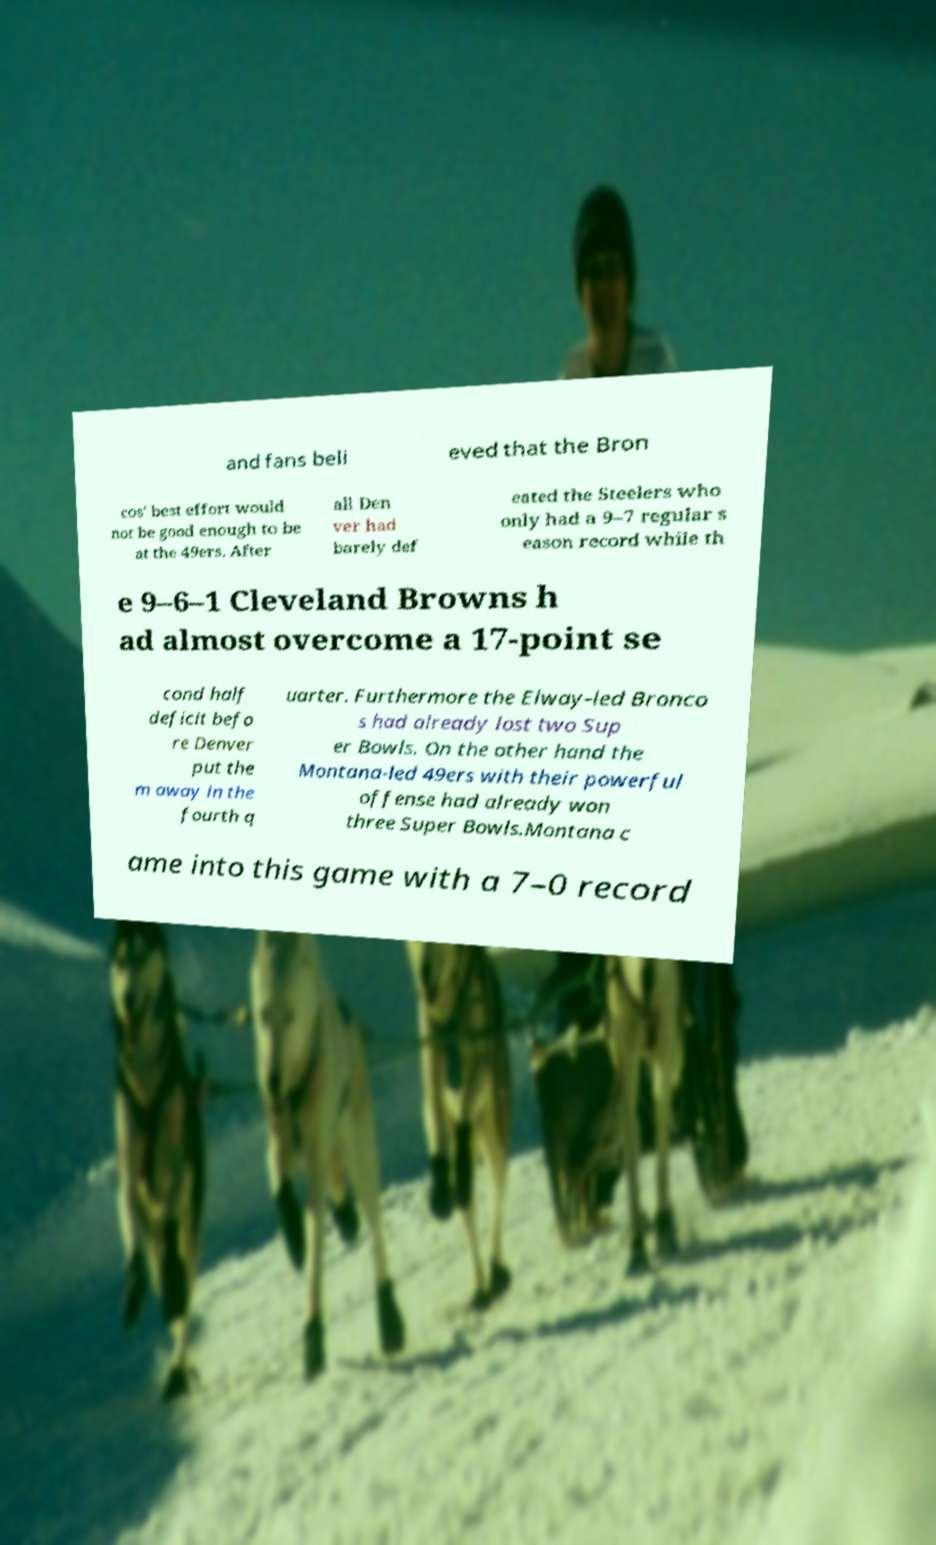Could you assist in decoding the text presented in this image and type it out clearly? and fans beli eved that the Bron cos' best effort would not be good enough to be at the 49ers. After all Den ver had barely def eated the Steelers who only had a 9–7 regular s eason record while th e 9–6–1 Cleveland Browns h ad almost overcome a 17-point se cond half deficit befo re Denver put the m away in the fourth q uarter. Furthermore the Elway-led Bronco s had already lost two Sup er Bowls. On the other hand the Montana-led 49ers with their powerful offense had already won three Super Bowls.Montana c ame into this game with a 7–0 record 